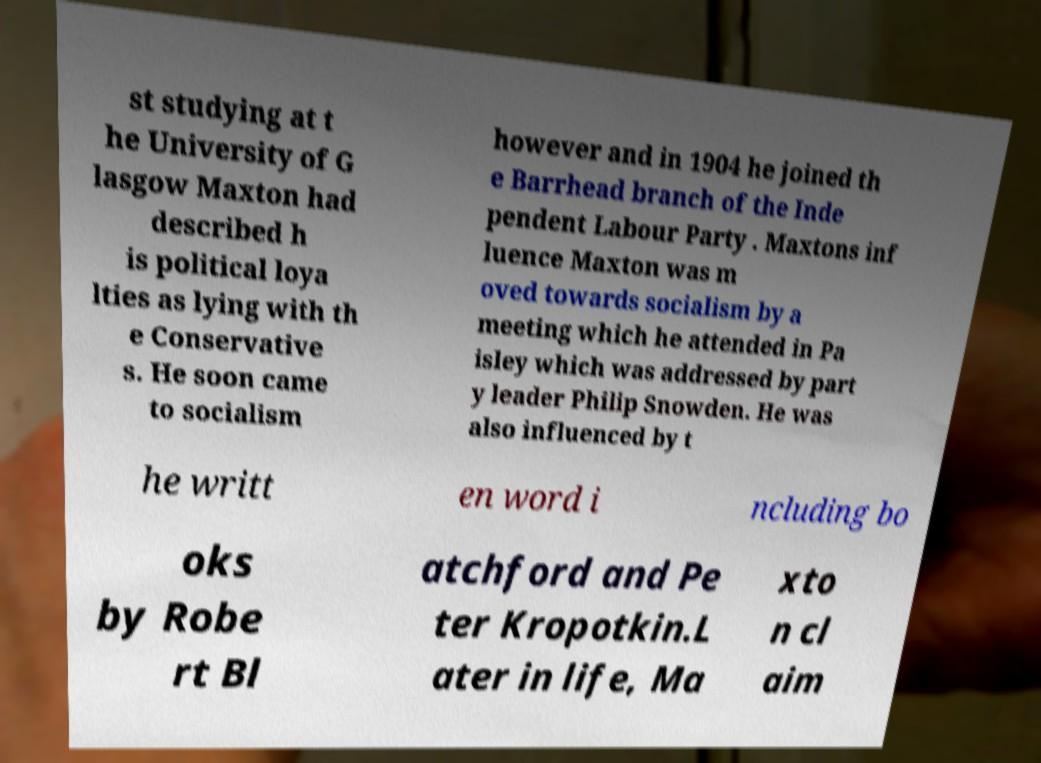Please identify and transcribe the text found in this image. st studying at t he University of G lasgow Maxton had described h is political loya lties as lying with th e Conservative s. He soon came to socialism however and in 1904 he joined th e Barrhead branch of the Inde pendent Labour Party . Maxtons inf luence Maxton was m oved towards socialism by a meeting which he attended in Pa isley which was addressed by part y leader Philip Snowden. He was also influenced by t he writt en word i ncluding bo oks by Robe rt Bl atchford and Pe ter Kropotkin.L ater in life, Ma xto n cl aim 